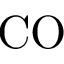<formula> <loc_0><loc_0><loc_500><loc_500>C O</formula> 